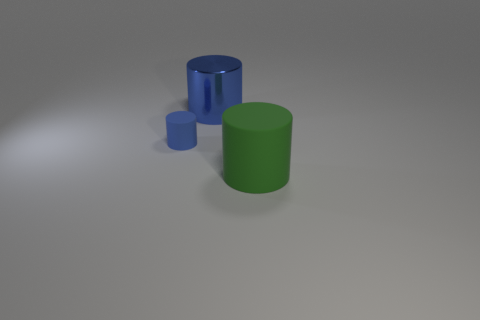The green rubber thing that is the same size as the blue metallic thing is what shape?
Give a very brief answer. Cylinder. Are the blue object that is to the right of the blue matte cylinder and the big cylinder in front of the small matte cylinder made of the same material?
Your answer should be compact. No. There is a cylinder in front of the blue cylinder in front of the large blue metallic cylinder; what is it made of?
Your response must be concise. Rubber. There is a matte cylinder that is to the left of the matte cylinder on the right side of the blue thing that is right of the small object; what size is it?
Provide a succinct answer. Small. Is the green cylinder the same size as the metal thing?
Your response must be concise. Yes. Do the thing on the right side of the big blue metal cylinder and the matte thing that is on the left side of the large green object have the same shape?
Offer a very short reply. Yes. Are there any big blue metal cylinders on the right side of the rubber cylinder that is in front of the small blue cylinder?
Ensure brevity in your answer.  No. Are any big objects visible?
Provide a succinct answer. Yes. What number of blue shiny objects have the same size as the green matte cylinder?
Provide a succinct answer. 1. What number of cylinders are both to the left of the blue shiny cylinder and right of the blue shiny cylinder?
Your response must be concise. 0. 